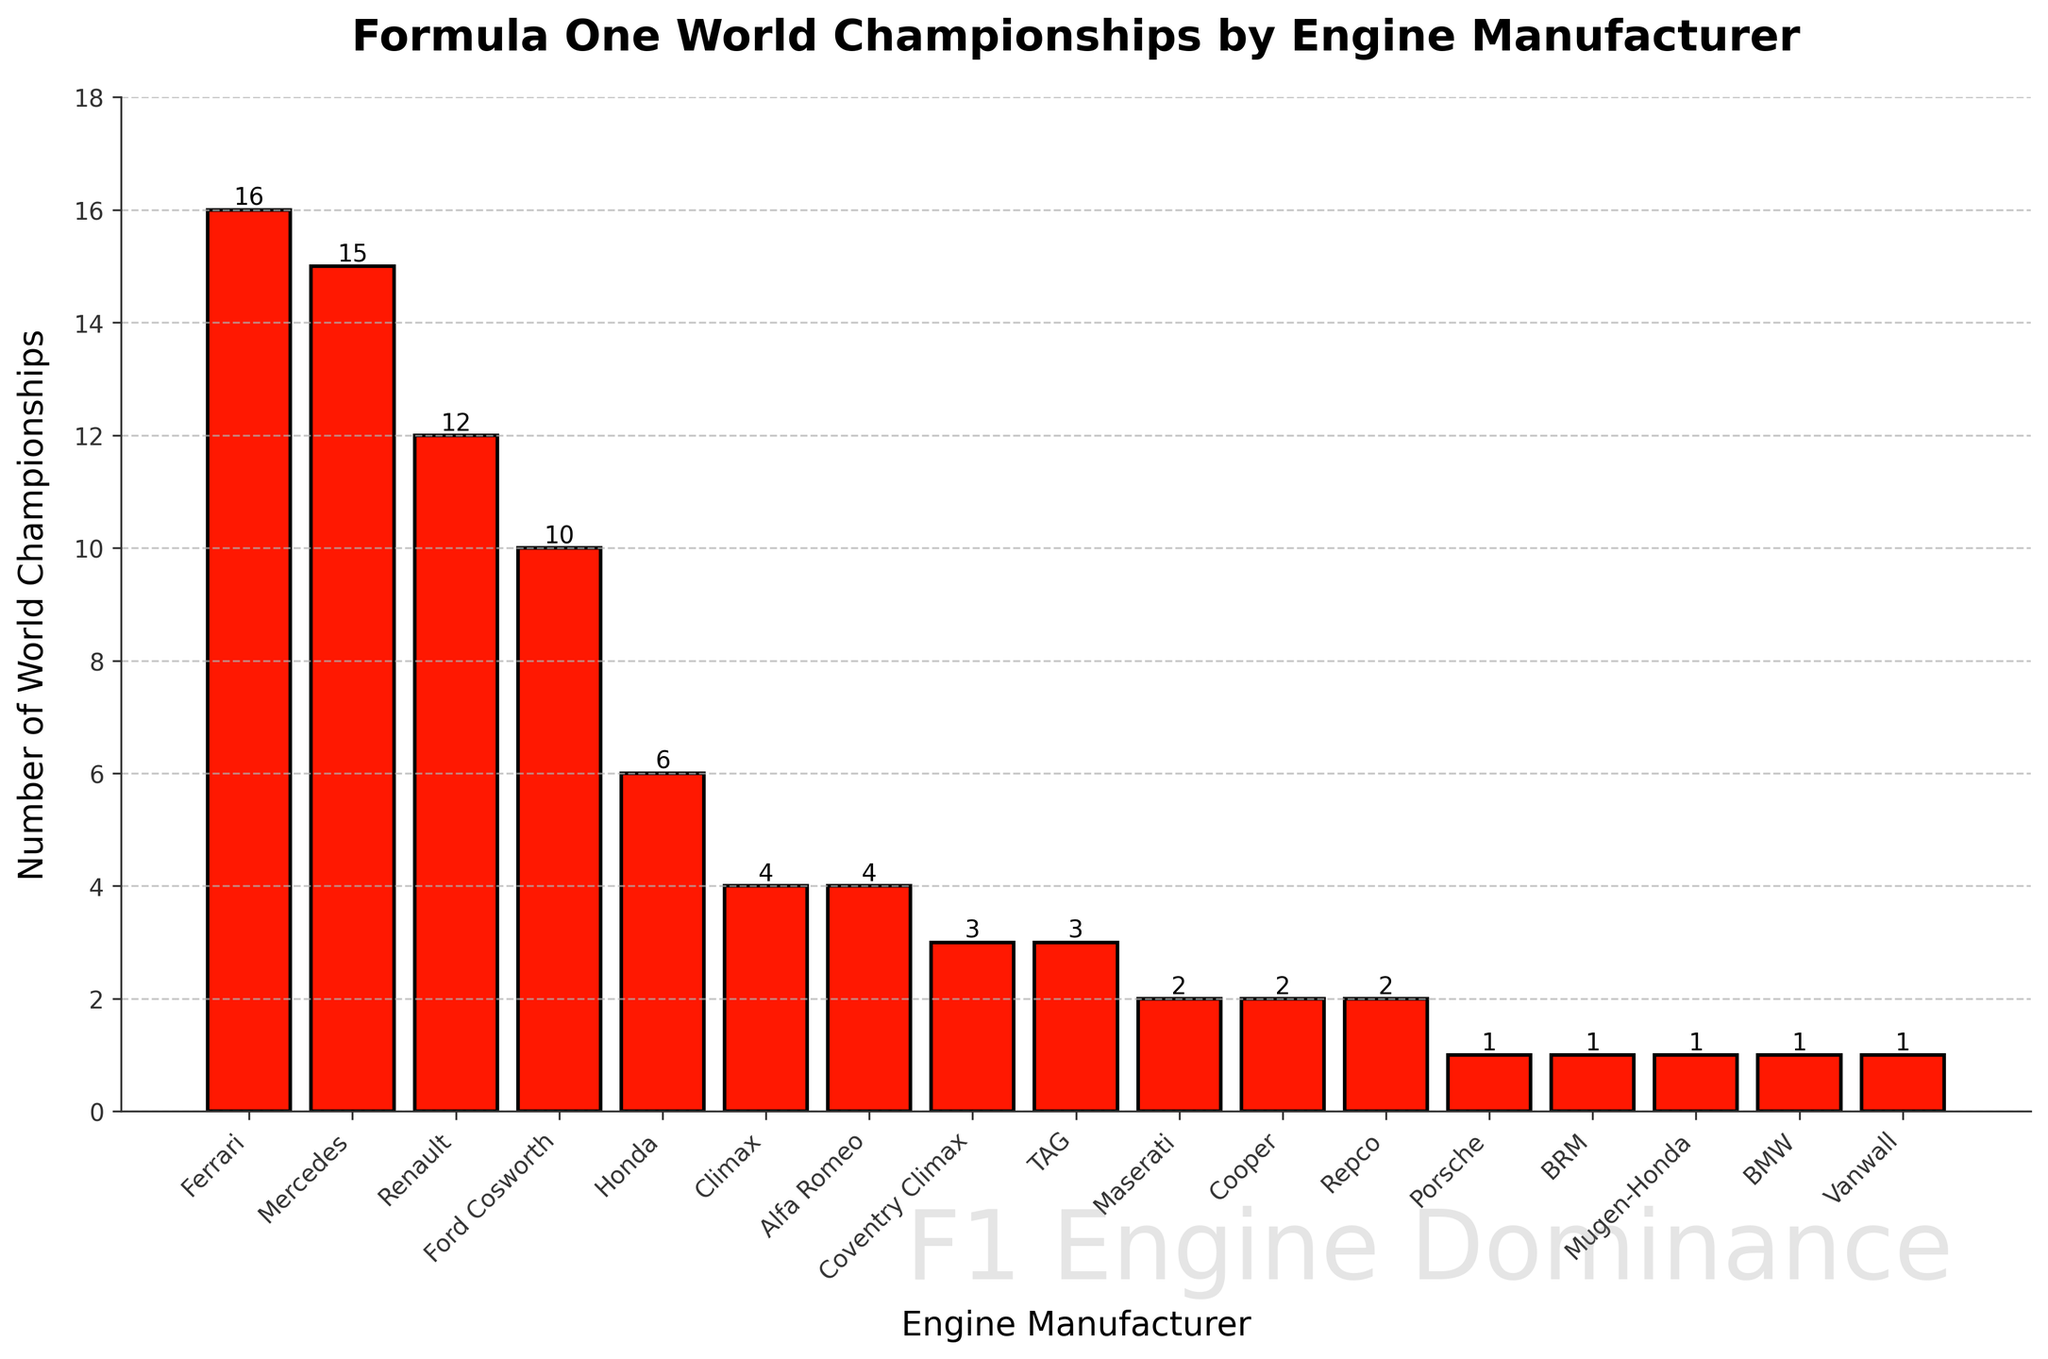Which engine manufacturer has won the most Formula One World Championships? The height of the bars can be compared to identify which bar is the tallest. The tallest bar represents Ferrari, which has won the most championships.
Answer: Ferrari How many championships have been won by manufacturers from Italy (Ferrari and Maserati)? Add the number of championships won by Ferrari and Maserati. Ferrari has 16, and Maserati has 2, so the total is 16 + 2 = 18.
Answer: 18 Which two engine manufacturers have won an equal number of World Championships? Identify the bars that have the same height. Both BMW and Porsche have bars with a height of 1 championship.
Answer: BMW and Porsche What is the difference in the number of championships between Ferrari and Renault? Subtract the number of championships won by Renault from those won by Ferrari. Ferrari has 16, Renault has 12, so the difference is 16 - 12 = 4.
Answer: 4 Which engine manufacturer has won the least number of World Championships? Identify the engine manufacturers with the shortest bars. Several manufacturers have won only one championship: BMW, BRM, Vanwall, Porsche, Mugen-Honda.
Answer: BMW, BRM, Vanwall, Porsche, Mugen-Honda How many more championships has Mercedes won compared to Ford Cosworth? Subtract the number of championships won by Ford Cosworth from those won by Mercedes. Mercedes has 15, Ford Cosworth has 10, so the difference is 15 - 10 = 5.
Answer: 5 What is the total number of championships won by all "Honda" branded engines combined (Honda and Mugen-Honda)? Add the number of championships won by Honda and Mugen-Honda. Honda has 6 and Mugen-Honda has 1, so the total is 6 + 1 = 7.
Answer: 7 Which engine manufacturer has the third-highest number of championships? After Ferrari and Mercedes, the next tallest bar represents Renault, which has the third-highest number of championships with 12.
Answer: Renault What is the combined total number of championships won by Alfa Romeo and Climax? Add the number of championships won by Alfa Romeo and Climax. Alfa Romeo has 4, and Climax has 4, so the sum is 4 + 4 = 8.
Answer: 8 